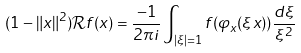<formula> <loc_0><loc_0><loc_500><loc_500>( 1 - \| x \| ^ { 2 } ) \mathcal { R } f ( x ) = \frac { - 1 } { 2 \pi i } \int _ { | \xi | = 1 } f ( \varphi _ { x } ( \xi x ) ) \frac { d \xi } { \xi ^ { 2 } } \Big .</formula> 